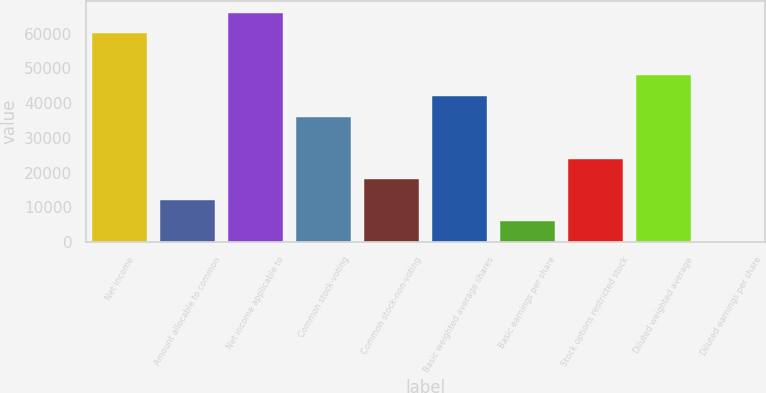Convert chart to OTSL. <chart><loc_0><loc_0><loc_500><loc_500><bar_chart><fcel>Net income<fcel>Amount allocable to common<fcel>Net income applicable to<fcel>Common stock-voting<fcel>Common stock-non-voting<fcel>Basic weighted average shares<fcel>Basic earnings per share<fcel>Stock options restricted stock<fcel>Diluted weighted average<fcel>Diluted earnings per share<nl><fcel>60069<fcel>12015.1<fcel>66075.7<fcel>36101<fcel>18021.8<fcel>42107.7<fcel>6008.33<fcel>24028.5<fcel>48114.5<fcel>1.59<nl></chart> 